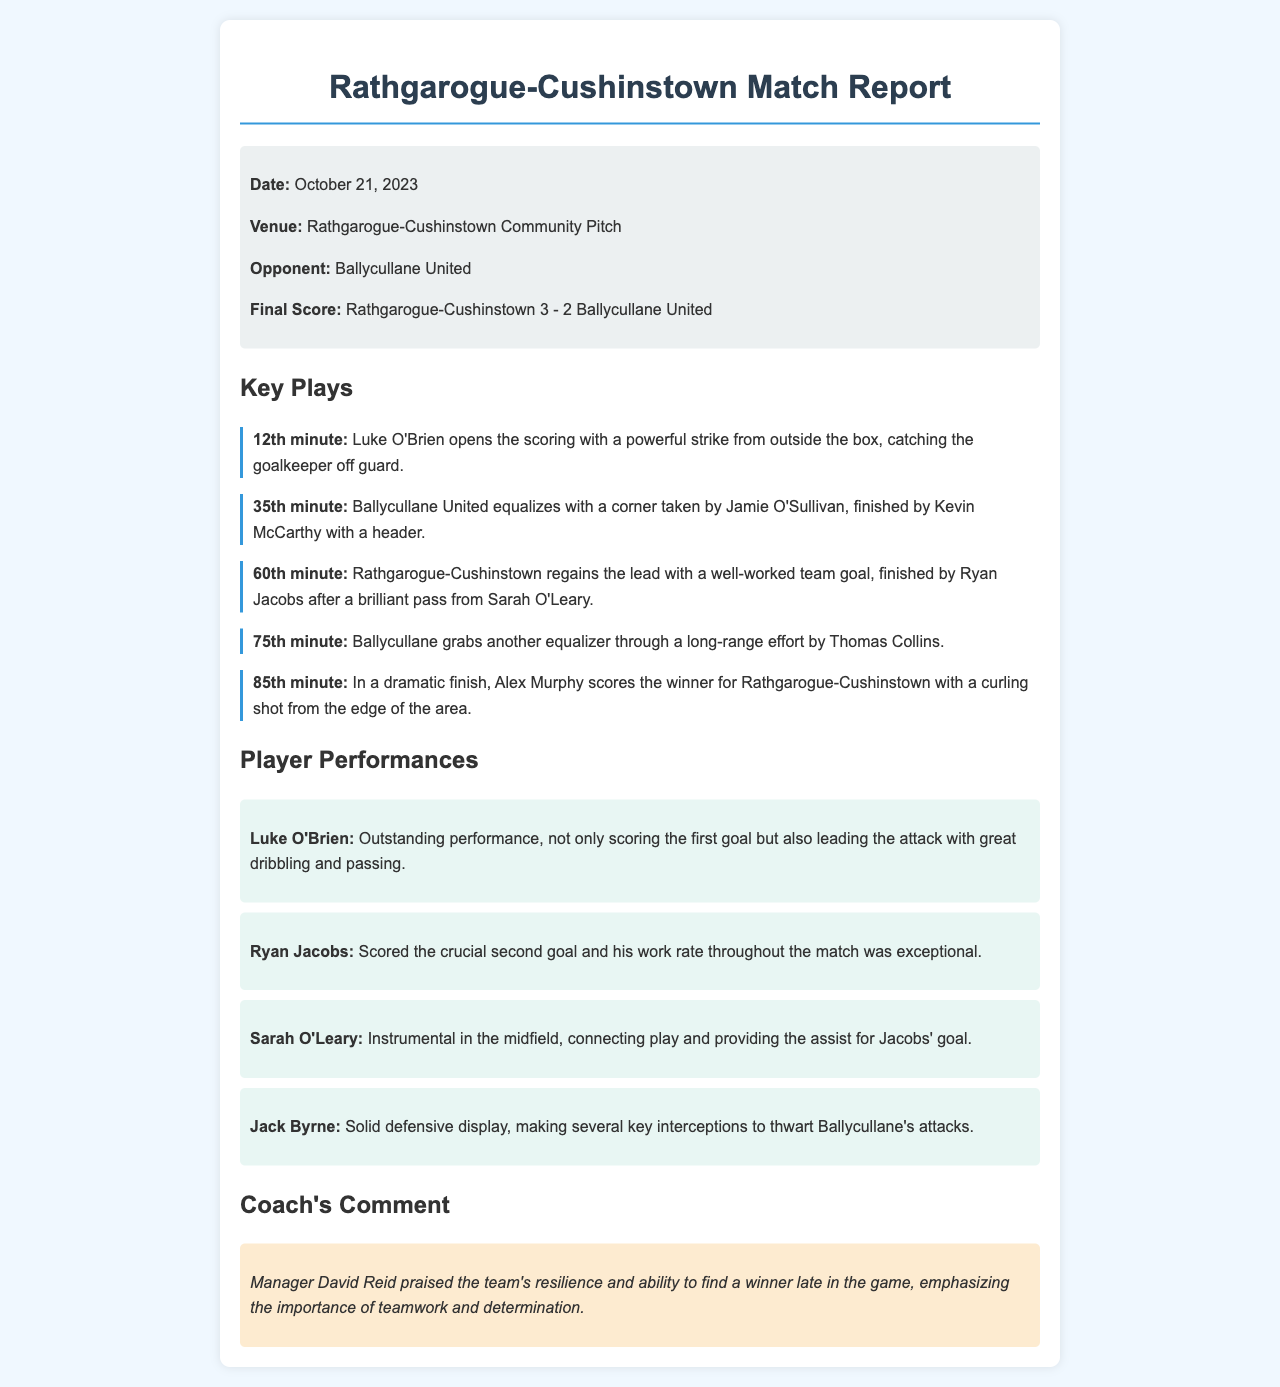What was the date of the match? The date of the match is provided in the match info section.
Answer: October 21, 2023 Who scored the first goal? The first goal scorer is mentioned in the key plays section of the document.
Answer: Luke O'Brien What was the final score of the match? The final score is stated clearly in the match info section.
Answer: Rathgarogue-Cushinstown 3 - 2 Ballycullane United How many goals did Ryan Jacobs score? The document specifies Ryan Jacobs' contribution in the player performances section.
Answer: 1 What play occurred in the 85th minute? The key plays section describes the significant events that occurred during the match by minute.
Answer: Alex Murphy scores the winner Who assisted Ryan Jacobs' goal? The document states the player who provided the assist in the key plays section.
Answer: Sarah O'Leary What is the venue of the match? The venue is specified in the match info section.
Answer: Rathgarogue-Cushinstown Community Pitch What did Coach David Reid emphasize about the team? The coach's comment provides insights into his thoughts on the team's performance.
Answer: Teamwork and determination 